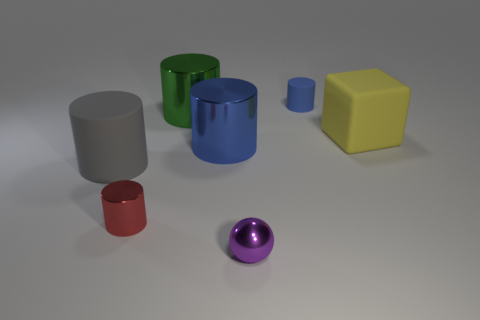There is a tiny object that is both on the left side of the tiny blue object and on the right side of the tiny metal cylinder; what is it made of?
Your response must be concise. Metal. There is a rubber cylinder behind the big gray cylinder; is it the same color as the large metal cylinder that is in front of the yellow block?
Provide a short and direct response. Yes. How many gray things are either matte cylinders or small spheres?
Your response must be concise. 1. Are there fewer small red cylinders behind the cube than blue rubber cylinders on the left side of the large green thing?
Offer a terse response. No. Are there any green things of the same size as the gray cylinder?
Offer a terse response. Yes. There is a green thing on the left side of the ball; does it have the same size as the tiny blue rubber object?
Your response must be concise. No. Is the number of tiny metal cylinders greater than the number of small cyan balls?
Provide a succinct answer. Yes. Is there a blue matte thing that has the same shape as the gray thing?
Make the answer very short. Yes. What is the shape of the blue thing to the right of the small purple ball?
Make the answer very short. Cylinder. There is a cylinder that is left of the cylinder in front of the large gray cylinder; what number of metal balls are in front of it?
Provide a short and direct response. 1. 